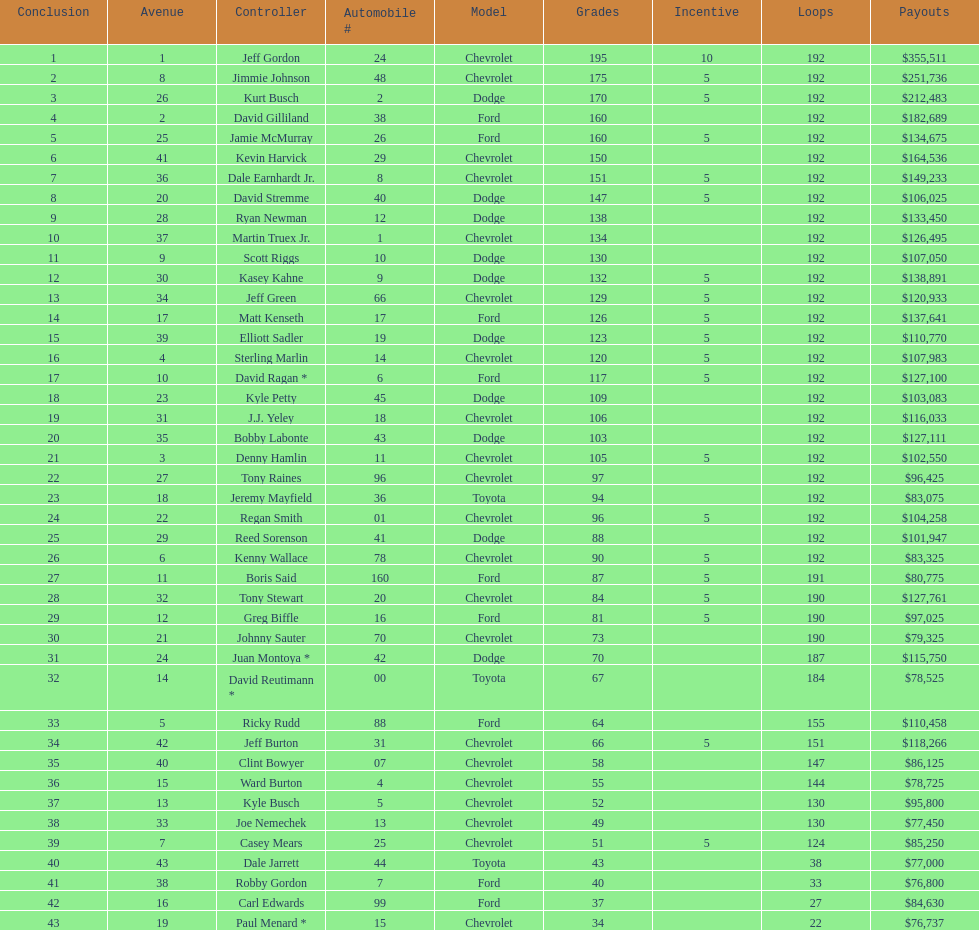Who is first in number of winnings on this list? Jeff Gordon. 